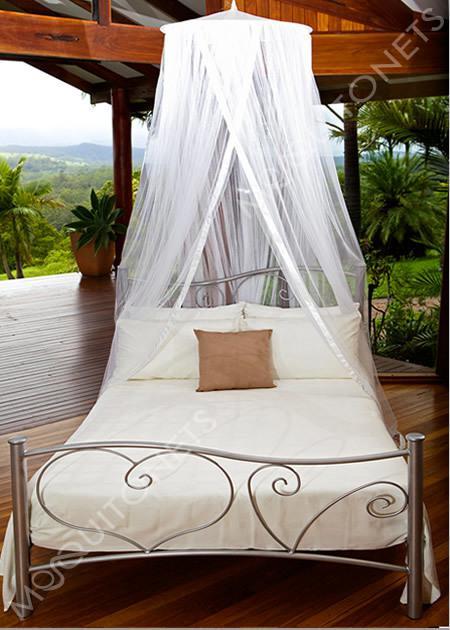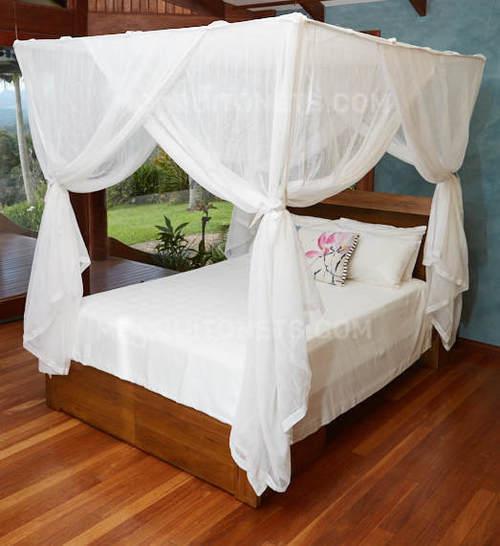The first image is the image on the left, the second image is the image on the right. Considering the images on both sides, is "One of the beds has a wooden frame." valid? Answer yes or no. Yes. 